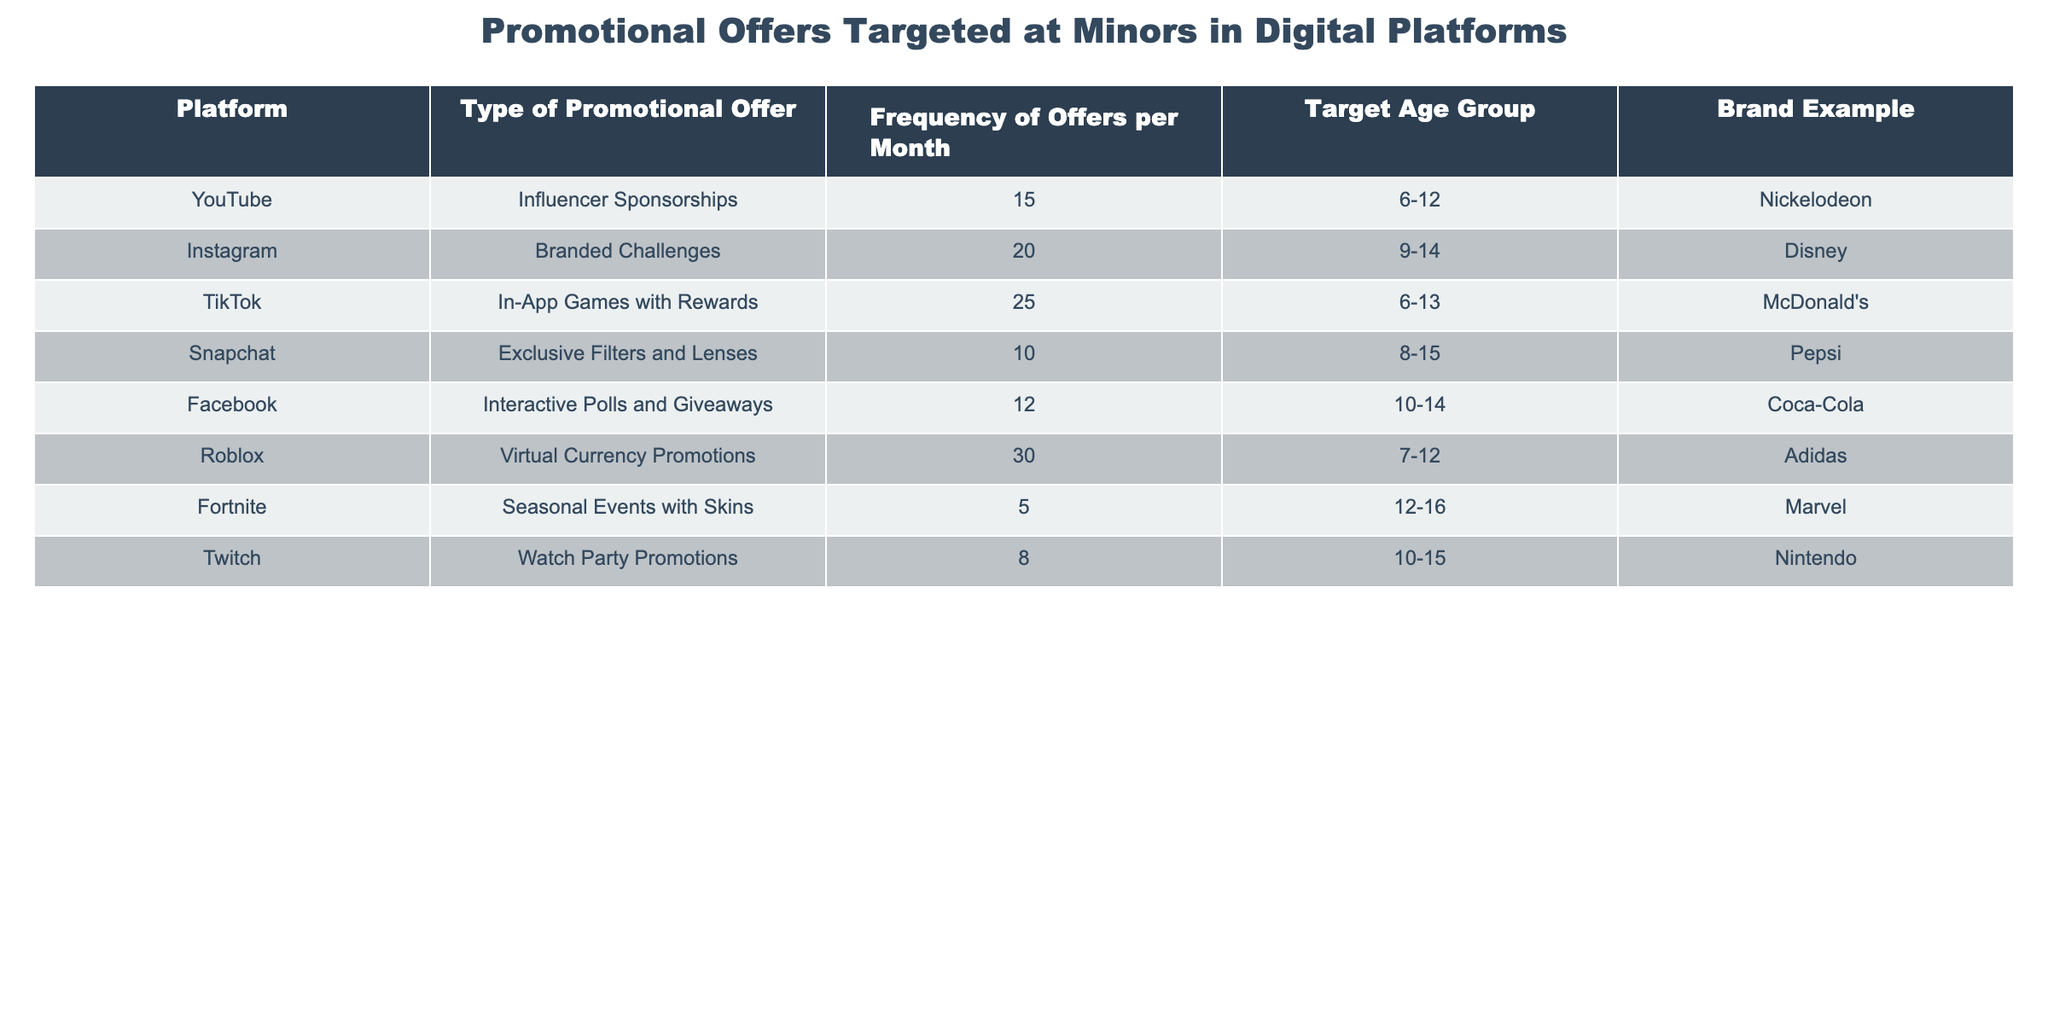What is the most frequent type of promotional offer targeted at minors? By looking at the "Frequency of Offers per Month" column, we see that the highest frequency is 30, which corresponds to "Virtual Currency Promotions" on Roblox.
Answer: Virtual Currency Promotions Which platform has the least frequency of promotional offers targeting minors? The lowest value in the "Frequency of Offers per Month" column is 5, which belongs to "Seasonal Events with Skins" on Fortnite.
Answer: Fortnite How many promotional offers are there per month for TikTok? TikTok is listed in the table, and its "Frequency of Offers per Month" is 25. Therefore, there are 25 offers per month for TikTok.
Answer: 25 Is there any promotional offer targeted at the age group 6-12 more frequent than 20? The offers targeted at ages 6-12 are "Influencer Sponsorships" on YouTube (15), "In-App Games with Rewards" on TikTok (25), and "Virtual Currency Promotions" on Roblox (30). Since 30 is greater than 20, the answer is yes.
Answer: Yes What is the average frequency of promotional offers for platforms targeting the age group 10-14? The frequency for platforms targeting ages 10-14 are: Instagram (20), Facebook (12), and Twitch (8). To find the average, we add these frequencies: 20 + 12 + 8 = 40, and divide by the number of platforms (3). Therefore, the average is 40/3 = 13.33.
Answer: 13.33 Are branded challenges more frequently offered on Instagram or exclusive filters on Snapchat? The frequency for Instagram's "Branded Challenges" is 20, while Snapchat's "Exclusive Filters and Lenses" has a frequency of 10. Therefore, the frequency for Instagram (20) is higher than for Snapchat (10), making the answer yes.
Answer: Yes What is the total frequency of promotional offers across all platforms? To find the total, we sum the frequency of offers for all platforms. That results in 15 + 20 + 25 + 10 + 12 + 30 + 5 + 8 = 125.
Answer: 125 Which brand example is associated with the highest frequency promotional offer? "Virtual Currency Promotions" associated with Adidas on Roblox has the highest frequency of 30.
Answer: Adidas How many platforms target the age group 12-16? The platforms targeting 12-16 are "Fortnite" and "Twitch," which totals to two platforms. Therefore, the answer is two.
Answer: 2 